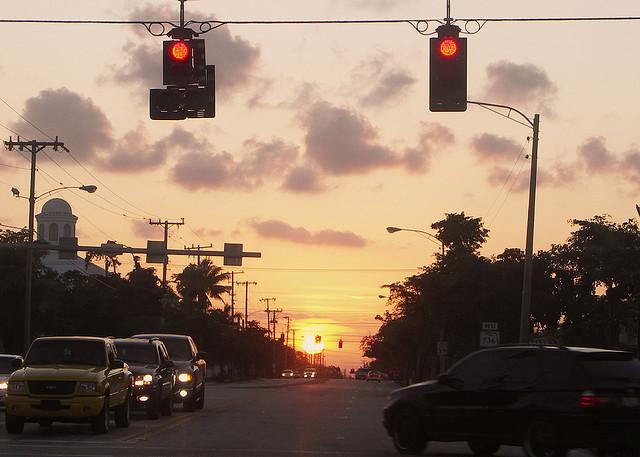Why do the cars have their lights on?
Be succinct. Sunset. Is it midnight in this picture?
Write a very short answer. No. Is the sun setting or rising?
Keep it brief. Setting. 